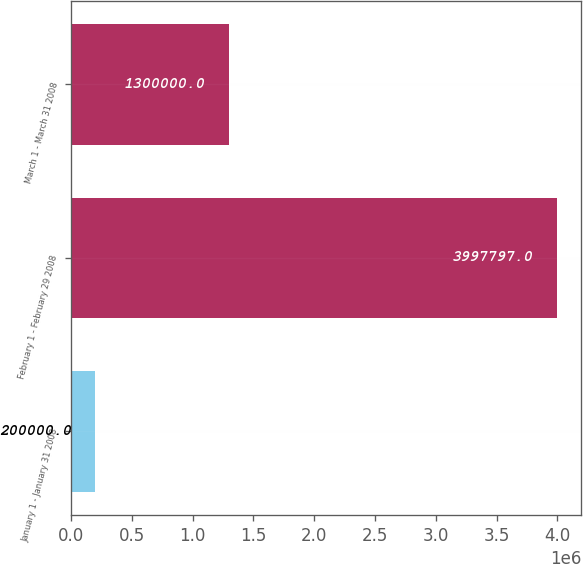Convert chart. <chart><loc_0><loc_0><loc_500><loc_500><bar_chart><fcel>January 1 - January 31 2008<fcel>February 1 - February 29 2008<fcel>March 1 - March 31 2008<nl><fcel>200000<fcel>3.9978e+06<fcel>1.3e+06<nl></chart> 